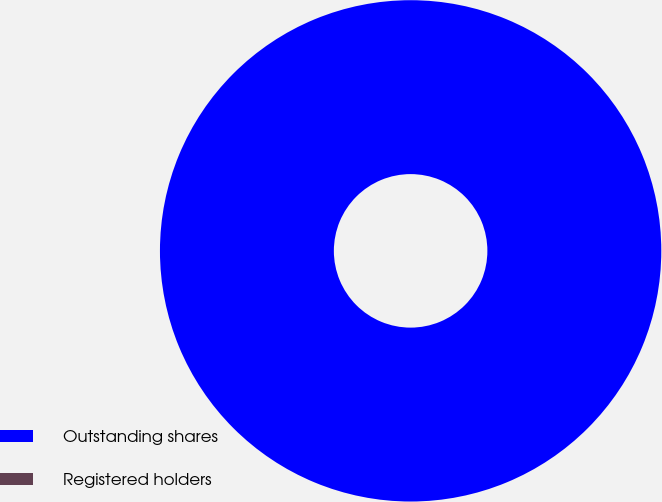Convert chart. <chart><loc_0><loc_0><loc_500><loc_500><pie_chart><fcel>Outstanding shares<fcel>Registered holders<nl><fcel>100.0%<fcel>0.0%<nl></chart> 